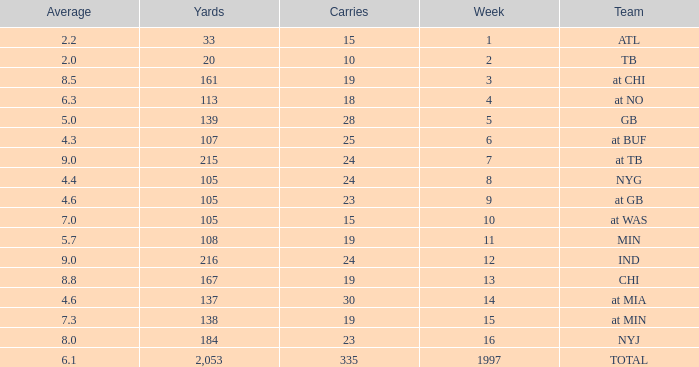Which group possesses 19 carries and a week exceeding 13? At min. 